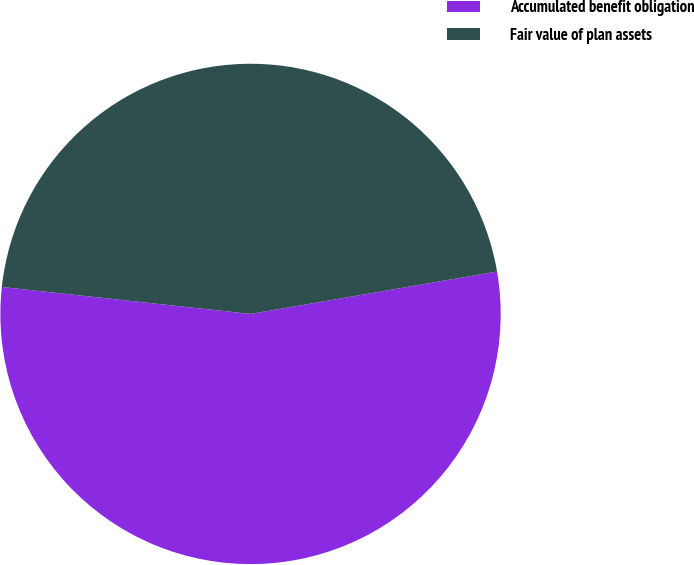Convert chart. <chart><loc_0><loc_0><loc_500><loc_500><pie_chart><fcel>Accumulated benefit obligation<fcel>Fair value of plan assets<nl><fcel>54.43%<fcel>45.57%<nl></chart> 